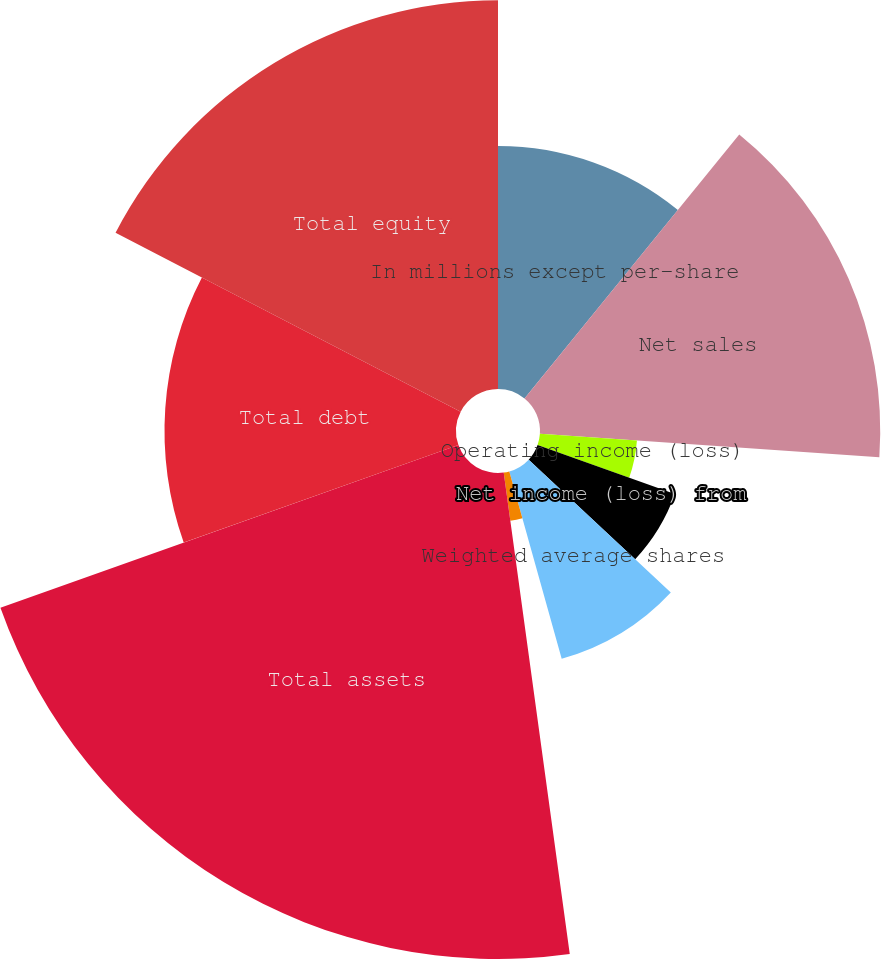<chart> <loc_0><loc_0><loc_500><loc_500><pie_chart><fcel>In millions except per-share<fcel>Net sales<fcel>Operating income (loss)<fcel>Net income (loss) from<fcel>Earnings (loss) per ordinary<fcel>Weighted average shares<fcel>Cash dividends declared and<fcel>Total assets<fcel>Total debt<fcel>Total equity<nl><fcel>10.87%<fcel>15.22%<fcel>4.35%<fcel>6.52%<fcel>0.0%<fcel>8.7%<fcel>2.17%<fcel>21.74%<fcel>13.04%<fcel>17.39%<nl></chart> 